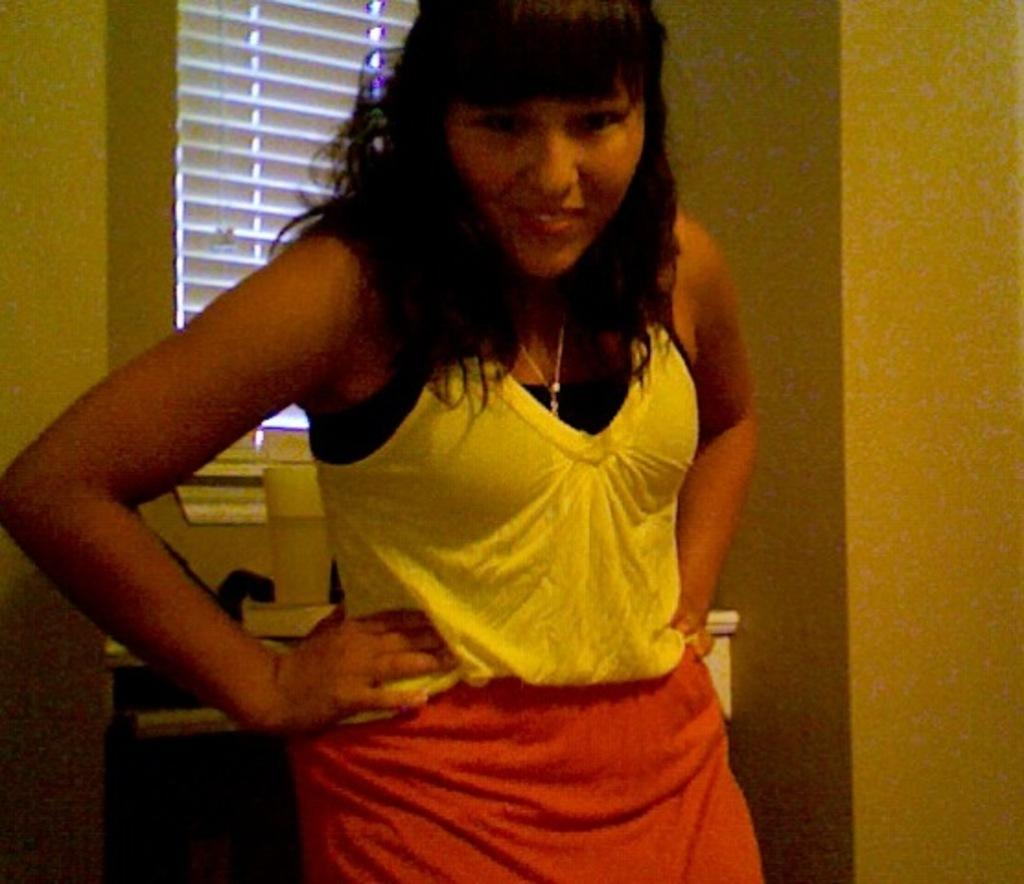What is the main subject in the image? There is a woman standing in the image. What can be seen in the background of the image? There is a window in the image. What object is placed in front of the window? There is a glass in front of the window. What type of creature can be seen walking through the hall in the image? There is no hall or creature present in the image. Is there a bear visible in the image? No, there is no bear present in the image. 